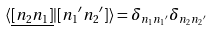<formula> <loc_0><loc_0><loc_500><loc_500>\langle \underline { [ n _ { 2 } n _ { 1 } ] } | [ n _ { 1 } { ^ { \prime } } n _ { 2 } { ^ { \prime } } ] \rangle = \delta _ { n _ { 1 } n _ { 1 } { ^ { \prime } } } \delta _ { n _ { 2 } n _ { 2 } { ^ { \prime } } }</formula> 